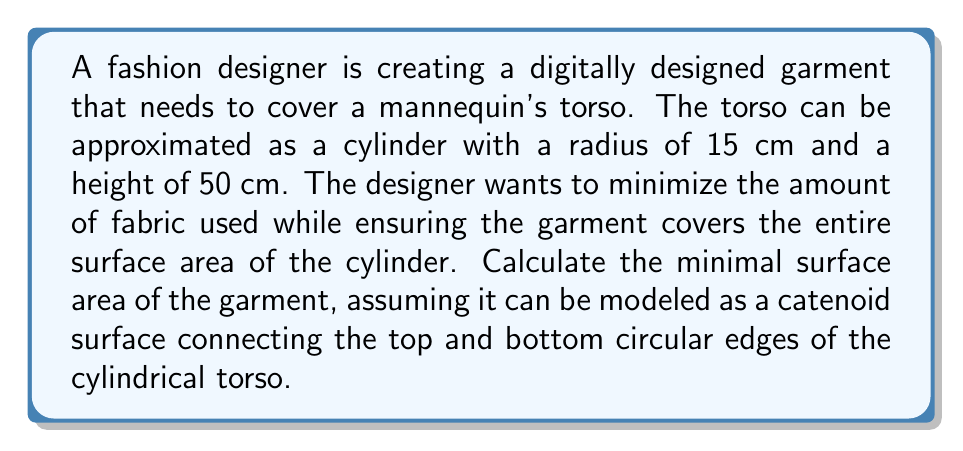Teach me how to tackle this problem. To solve this problem, we need to follow these steps:

1) First, recall that a catenoid is a minimal surface formed by rotating a catenary curve around an axis. The surface area of a catenoid is given by:

   $$A = 2\pi a^2 \left(\cosh\left(\frac{h}{a}\right) - 1\right)$$

   where $a$ is the minimum radius of the catenoid's "neck" and $h$ is half the height of the catenoid.

2) In our case, the height of the cylinder is 50 cm, so $h = 25$ cm.

3) The radius at the top and bottom of the catenoid must match the cylinder's radius, which is 15 cm. We need to find the value of $a$ that minimizes the surface area while satisfying this constraint.

4) The relationship between the cylinder radius $r$, the catenoid parameter $a$, and the height $h$ is given by:

   $$r = a \cosh\left(\frac{h}{a}\right)$$

5) Substituting our known values:

   $$15 = a \cosh\left(\frac{25}{a}\right)$$

6) This equation can't be solved analytically, so we need to use numerical methods. Using a computer algebra system or numerical solver, we find:

   $a \approx 13.205$ cm

7) Now we can calculate the minimal surface area by substituting this value of $a$ and $h = 25$ cm into the surface area formula:

   $$A = 2\pi (13.205)^2 \left(\cosh\left(\frac{25}{13.205}\right) - 1\right)$$

8) Evaluating this expression:

   $$A \approx 4719.4\text{ cm}^2$$

This is the minimal surface area of the garment that covers the cylindrical torso.
Answer: $4719.4\text{ cm}^2$ 